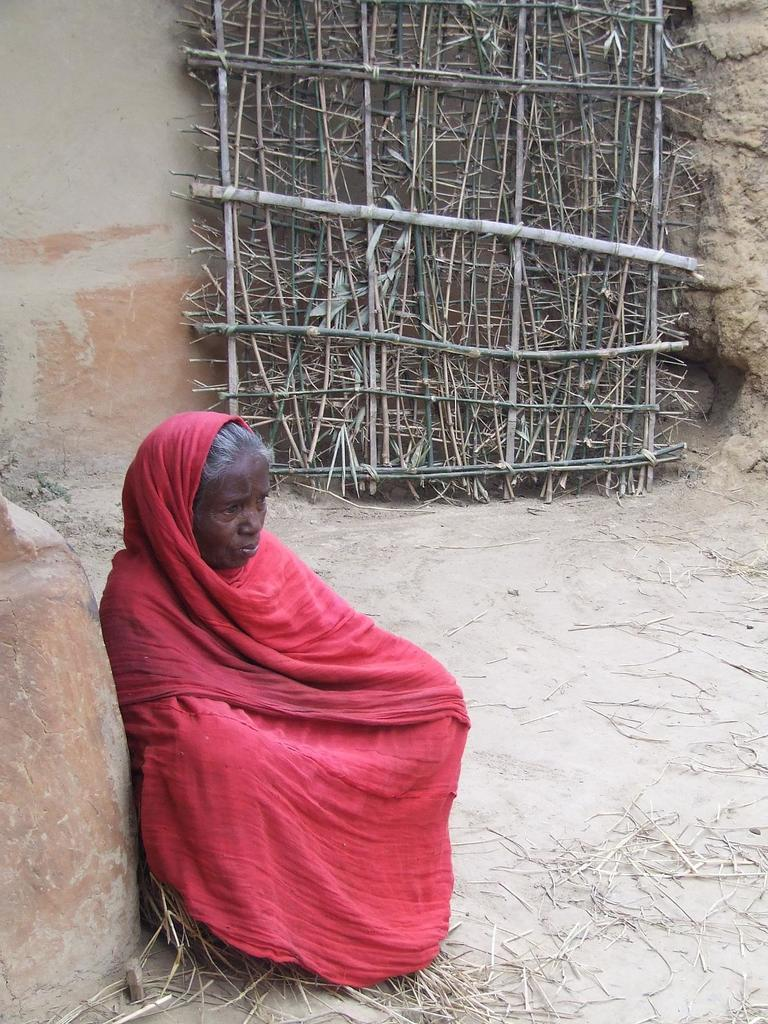Who is the main subject in the image? There is an old woman in the image. What is the old woman wearing? The old woman is wearing a red dress. What is the old woman's position in the image? The old woman is sitting on the ground. What can be seen in the background of the image? There is a bamboo structure and a straw frame visible in the background. What news is the old woman reading in the image? There is no newspaper or any news source visible in the image, so it cannot be determined if the old woman is reading any news. 